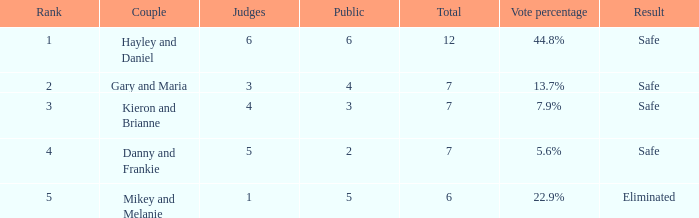6%? 4.0. 